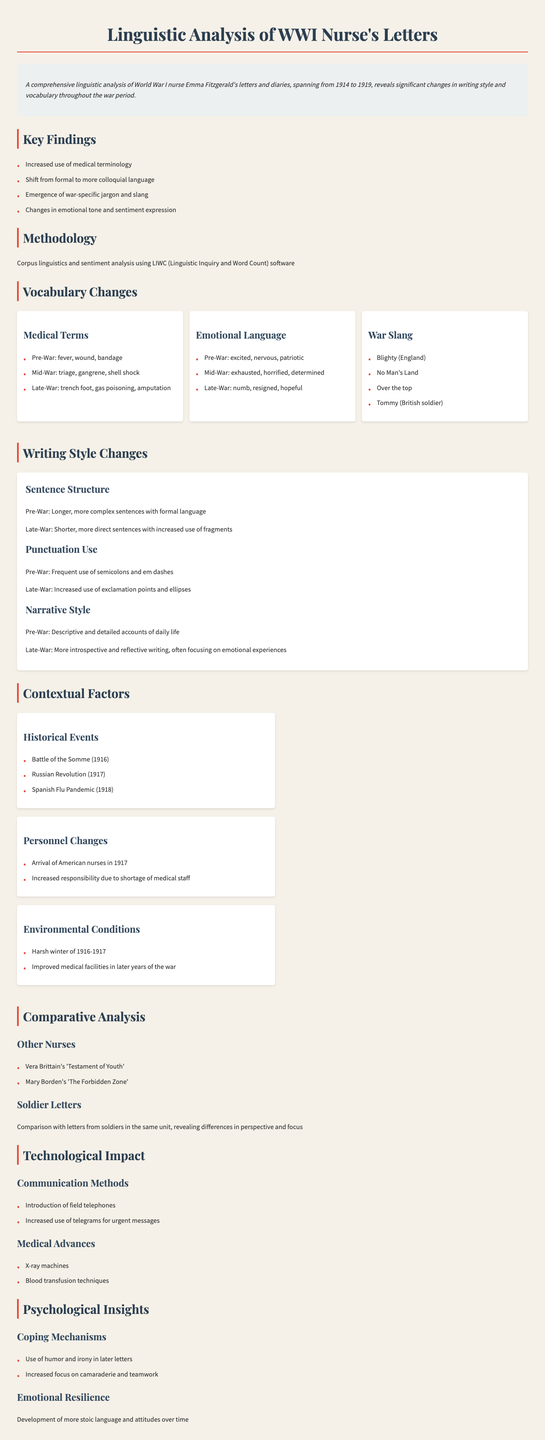What significant changes in writing style are identified? The document mentions significant changes in writing style throughout the war period.
Answer: Increased use of medical terminology What emotional language was predominant in the late-war letters? The document lists emotional language used at different stages, highlighting those from late-war letters.
Answer: Numb Which historical event occurred in 1916? The document lists historical events related to the context of the letters, indicating specific years.
Answer: Battle of the Somme What type of language shift was observed in Emma Fitzgerald's letters? The document contrasts formal and colloquial language use over time.
Answer: Shift from formal to more colloquial language Name one coping mechanism identified in the psychological insights section. The document specifies mechanisms nurses employed to cope with their experiences during the war.
Answer: Use of humor and irony What was the predominant sentence structure in pre-war letters? The document characterizes sentence structure at different periods of the war, focusing on complexity.
Answer: Longer, more complex sentences with formal language Which technological advancement was noted in medical practices during the war? The document lists medical advances that impacted nursing and treatment during the war.
Answer: Blood transfusion techniques How many key findings are presented in the overview? The document provides a list of key findings related to the linguistic analysis.
Answer: Four 